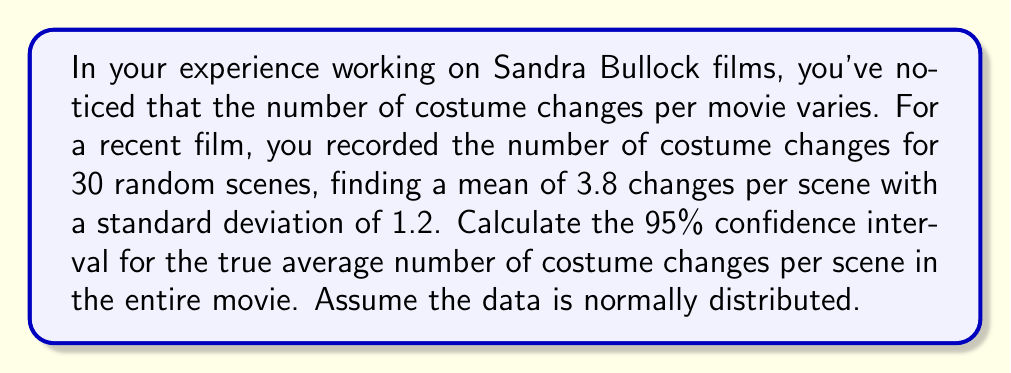Teach me how to tackle this problem. Let's approach this step-by-step:

1) We're given:
   - Sample size: $n = 30$
   - Sample mean: $\bar{x} = 3.8$
   - Sample standard deviation: $s = 1.2$
   - Confidence level: 95%

2) For a 95% confidence interval, we use a z-score of 1.96 (assuming a large sample size).

3) The formula for the confidence interval is:

   $$\bar{x} \pm z \cdot \frac{s}{\sqrt{n}}$$

4) Let's calculate the standard error:
   
   $$SE = \frac{s}{\sqrt{n}} = \frac{1.2}{\sqrt{30}} = \frac{1.2}{5.477} = 0.219$$

5) Now, let's calculate the margin of error:

   $$ME = z \cdot SE = 1.96 \cdot 0.219 = 0.429$$

6) Finally, we can calculate the confidence interval:

   Lower bound: $3.8 - 0.429 = 3.371$
   Upper bound: $3.8 + 0.429 = 4.229$

Therefore, we are 95% confident that the true average number of costume changes per scene in the entire movie is between 3.371 and 4.229.
Answer: (3.371, 4.229) 